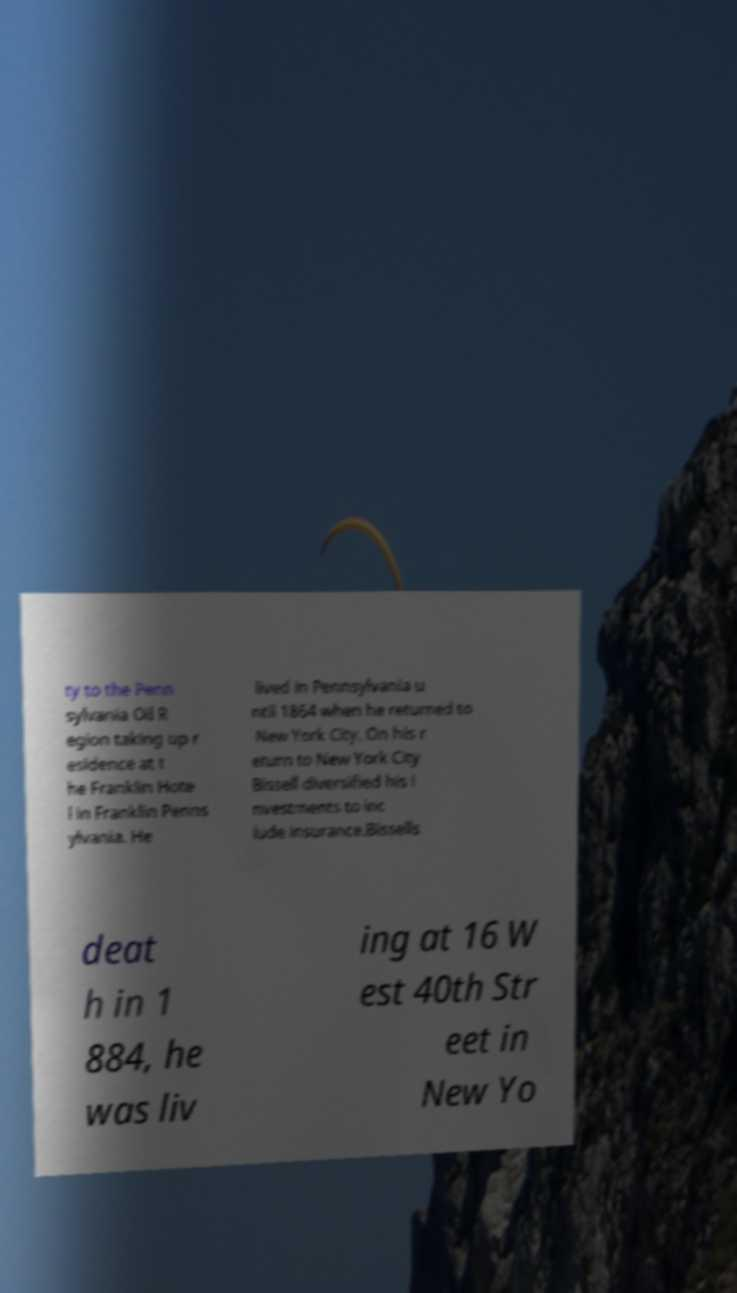I need the written content from this picture converted into text. Can you do that? ty to the Penn sylvania Oil R egion taking up r esidence at t he Franklin Hote l in Franklin Penns ylvania. He lived in Pennsylvania u ntil 1864 when he returned to New York City. On his r eturn to New York City Bissell diversified his i nvestments to inc lude insurance.Bissells deat h in 1 884, he was liv ing at 16 W est 40th Str eet in New Yo 